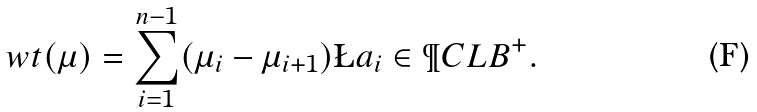<formula> <loc_0><loc_0><loc_500><loc_500>\sl w t ( \mu ) = \sum _ { i = 1 } ^ { n - 1 } ( \mu _ { i } - \mu _ { i + 1 } ) \L a _ { i } \in \P C L B ^ { + } .</formula> 